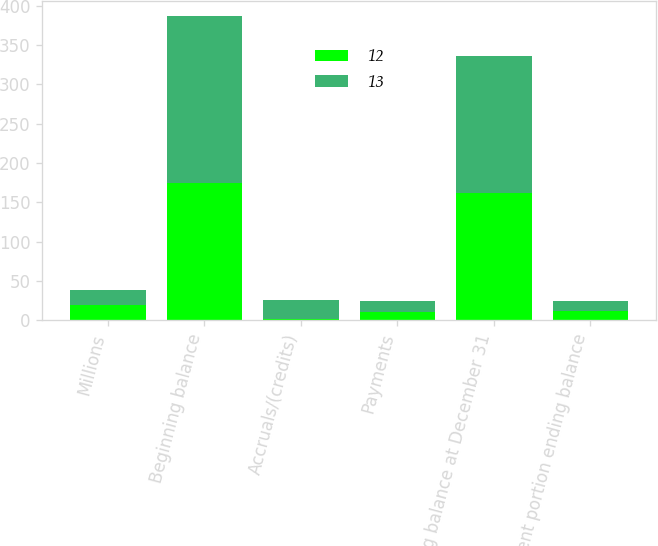<chart> <loc_0><loc_0><loc_500><loc_500><stacked_bar_chart><ecel><fcel>Millions<fcel>Beginning balance<fcel>Accruals/(credits)<fcel>Payments<fcel>Ending balance at December 31<fcel>Current portion ending balance<nl><fcel>12<fcel>19.5<fcel>174<fcel>1<fcel>11<fcel>162<fcel>12<nl><fcel>13<fcel>19.5<fcel>213<fcel>25<fcel>14<fcel>174<fcel>13<nl></chart> 